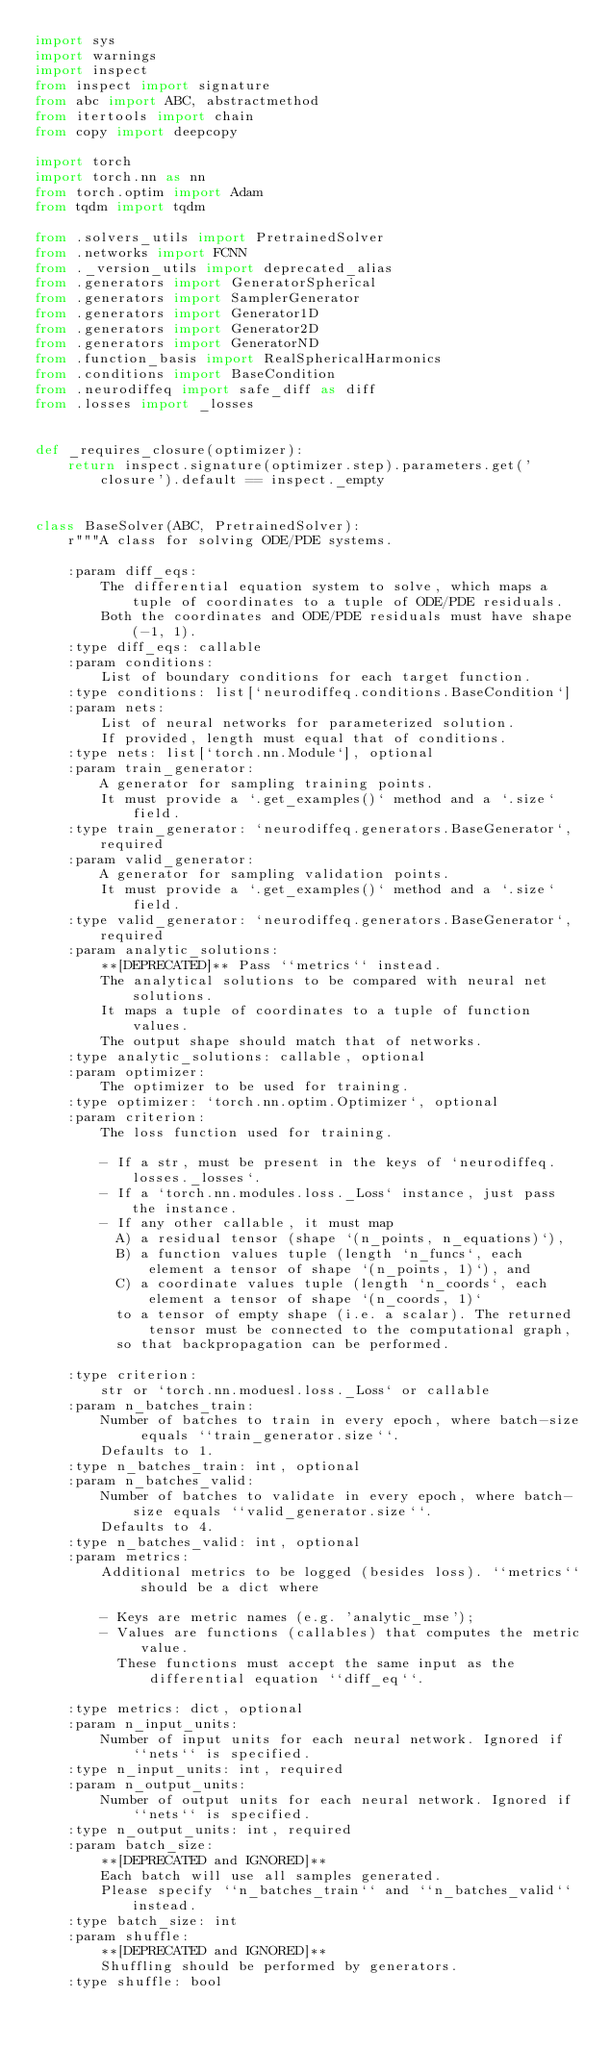Convert code to text. <code><loc_0><loc_0><loc_500><loc_500><_Python_>import sys
import warnings
import inspect
from inspect import signature
from abc import ABC, abstractmethod
from itertools import chain
from copy import deepcopy

import torch
import torch.nn as nn
from torch.optim import Adam
from tqdm import tqdm

from .solvers_utils import PretrainedSolver
from .networks import FCNN
from ._version_utils import deprecated_alias
from .generators import GeneratorSpherical
from .generators import SamplerGenerator
from .generators import Generator1D
from .generators import Generator2D
from .generators import GeneratorND
from .function_basis import RealSphericalHarmonics
from .conditions import BaseCondition
from .neurodiffeq import safe_diff as diff
from .losses import _losses


def _requires_closure(optimizer):
    return inspect.signature(optimizer.step).parameters.get('closure').default == inspect._empty


class BaseSolver(ABC, PretrainedSolver):
    r"""A class for solving ODE/PDE systems.

    :param diff_eqs:
        The differential equation system to solve, which maps a tuple of coordinates to a tuple of ODE/PDE residuals.
        Both the coordinates and ODE/PDE residuals must have shape (-1, 1).
    :type diff_eqs: callable
    :param conditions:
        List of boundary conditions for each target function.
    :type conditions: list[`neurodiffeq.conditions.BaseCondition`]
    :param nets:
        List of neural networks for parameterized solution.
        If provided, length must equal that of conditions.
    :type nets: list[`torch.nn.Module`], optional
    :param train_generator:
        A generator for sampling training points.
        It must provide a `.get_examples()` method and a `.size` field.
    :type train_generator: `neurodiffeq.generators.BaseGenerator`, required
    :param valid_generator:
        A generator for sampling validation points.
        It must provide a `.get_examples()` method and a `.size` field.
    :type valid_generator: `neurodiffeq.generators.BaseGenerator`, required
    :param analytic_solutions:
        **[DEPRECATED]** Pass ``metrics`` instead.
        The analytical solutions to be compared with neural net solutions.
        It maps a tuple of coordinates to a tuple of function values.
        The output shape should match that of networks.
    :type analytic_solutions: callable, optional
    :param optimizer:
        The optimizer to be used for training.
    :type optimizer: `torch.nn.optim.Optimizer`, optional
    :param criterion:
        The loss function used for training.

        - If a str, must be present in the keys of `neurodiffeq.losses._losses`.
        - If a `torch.nn.modules.loss._Loss` instance, just pass the instance.
        - If any other callable, it must map
          A) a residual tensor (shape `(n_points, n_equations)`),
          B) a function values tuple (length `n_funcs`, each element a tensor of shape `(n_points, 1)`), and
          C) a coordinate values tuple (length `n_coords`, each element a tensor of shape `(n_coords, 1)`
          to a tensor of empty shape (i.e. a scalar). The returned tensor must be connected to the computational graph,
          so that backpropagation can be performed.

    :type criterion:
        str or `torch.nn.moduesl.loss._Loss` or callable
    :param n_batches_train:
        Number of batches to train in every epoch, where batch-size equals ``train_generator.size``.
        Defaults to 1.
    :type n_batches_train: int, optional
    :param n_batches_valid:
        Number of batches to validate in every epoch, where batch-size equals ``valid_generator.size``.
        Defaults to 4.
    :type n_batches_valid: int, optional
    :param metrics:
        Additional metrics to be logged (besides loss). ``metrics`` should be a dict where

        - Keys are metric names (e.g. 'analytic_mse');
        - Values are functions (callables) that computes the metric value.
          These functions must accept the same input as the differential equation ``diff_eq``.

    :type metrics: dict, optional
    :param n_input_units:
        Number of input units for each neural network. Ignored if ``nets`` is specified.
    :type n_input_units: int, required
    :param n_output_units:
        Number of output units for each neural network. Ignored if ``nets`` is specified.
    :type n_output_units: int, required
    :param batch_size:
        **[DEPRECATED and IGNORED]**
        Each batch will use all samples generated.
        Please specify ``n_batches_train`` and ``n_batches_valid`` instead.
    :type batch_size: int
    :param shuffle:
        **[DEPRECATED and IGNORED]**
        Shuffling should be performed by generators.
    :type shuffle: bool</code> 